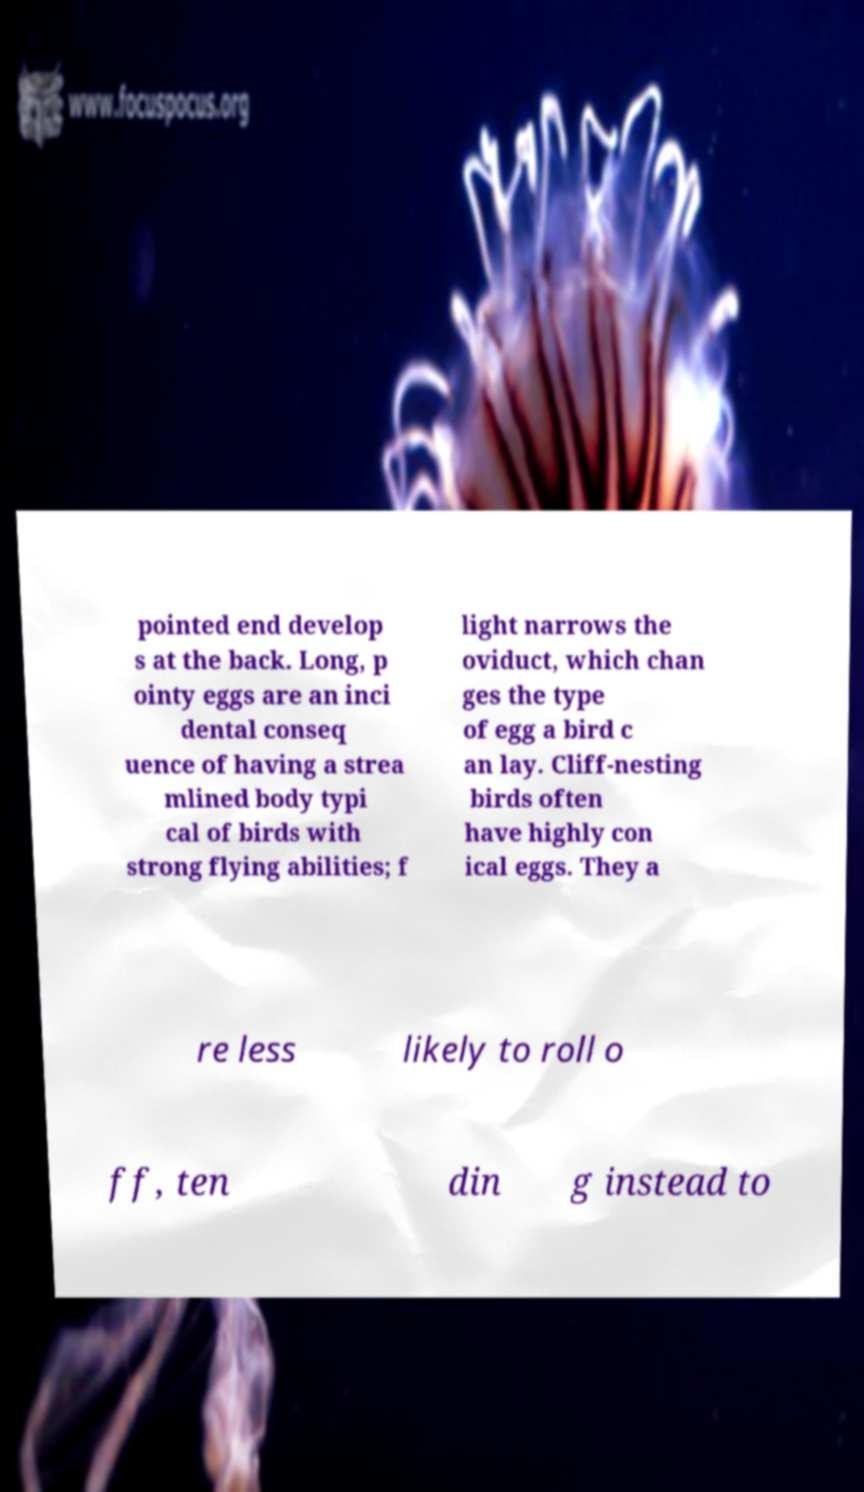Please identify and transcribe the text found in this image. pointed end develop s at the back. Long, p ointy eggs are an inci dental conseq uence of having a strea mlined body typi cal of birds with strong flying abilities; f light narrows the oviduct, which chan ges the type of egg a bird c an lay. Cliff-nesting birds often have highly con ical eggs. They a re less likely to roll o ff, ten din g instead to 